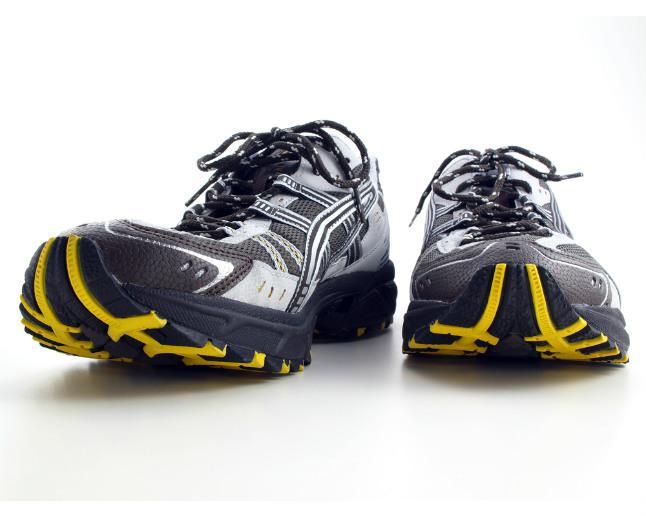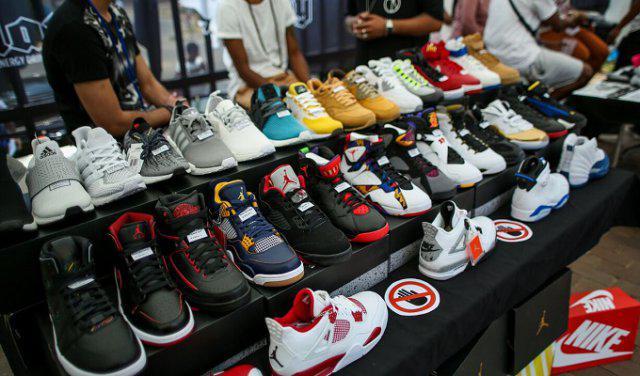The first image is the image on the left, the second image is the image on the right. Analyze the images presented: Is the assertion "One image shows only one pair of black shoes with white and yellow trim." valid? Answer yes or no. Yes. 